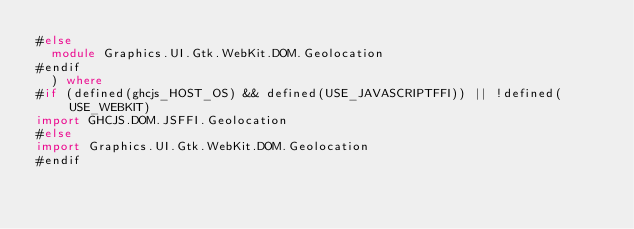<code> <loc_0><loc_0><loc_500><loc_500><_Haskell_>#else
  module Graphics.UI.Gtk.WebKit.DOM.Geolocation
#endif
  ) where
#if (defined(ghcjs_HOST_OS) && defined(USE_JAVASCRIPTFFI)) || !defined(USE_WEBKIT)
import GHCJS.DOM.JSFFI.Geolocation
#else
import Graphics.UI.Gtk.WebKit.DOM.Geolocation
#endif
</code> 